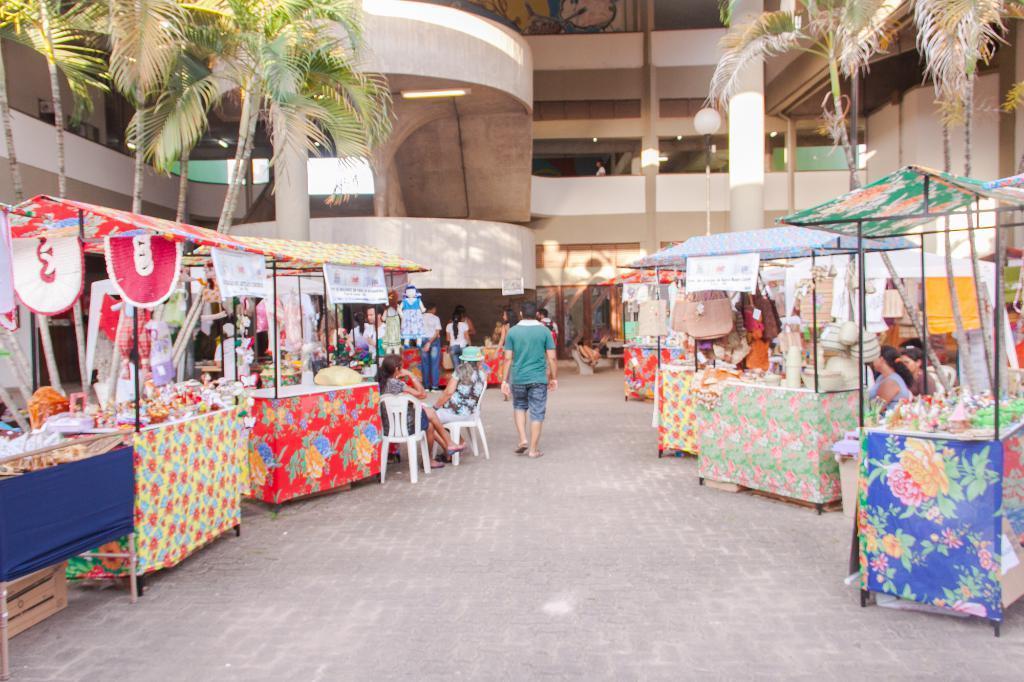In one or two sentences, can you explain what this image depicts? Here we can see stalls with banners, bags and things. In-front of this building there are trees, light pole and people. Few people are sitting on chairs. 